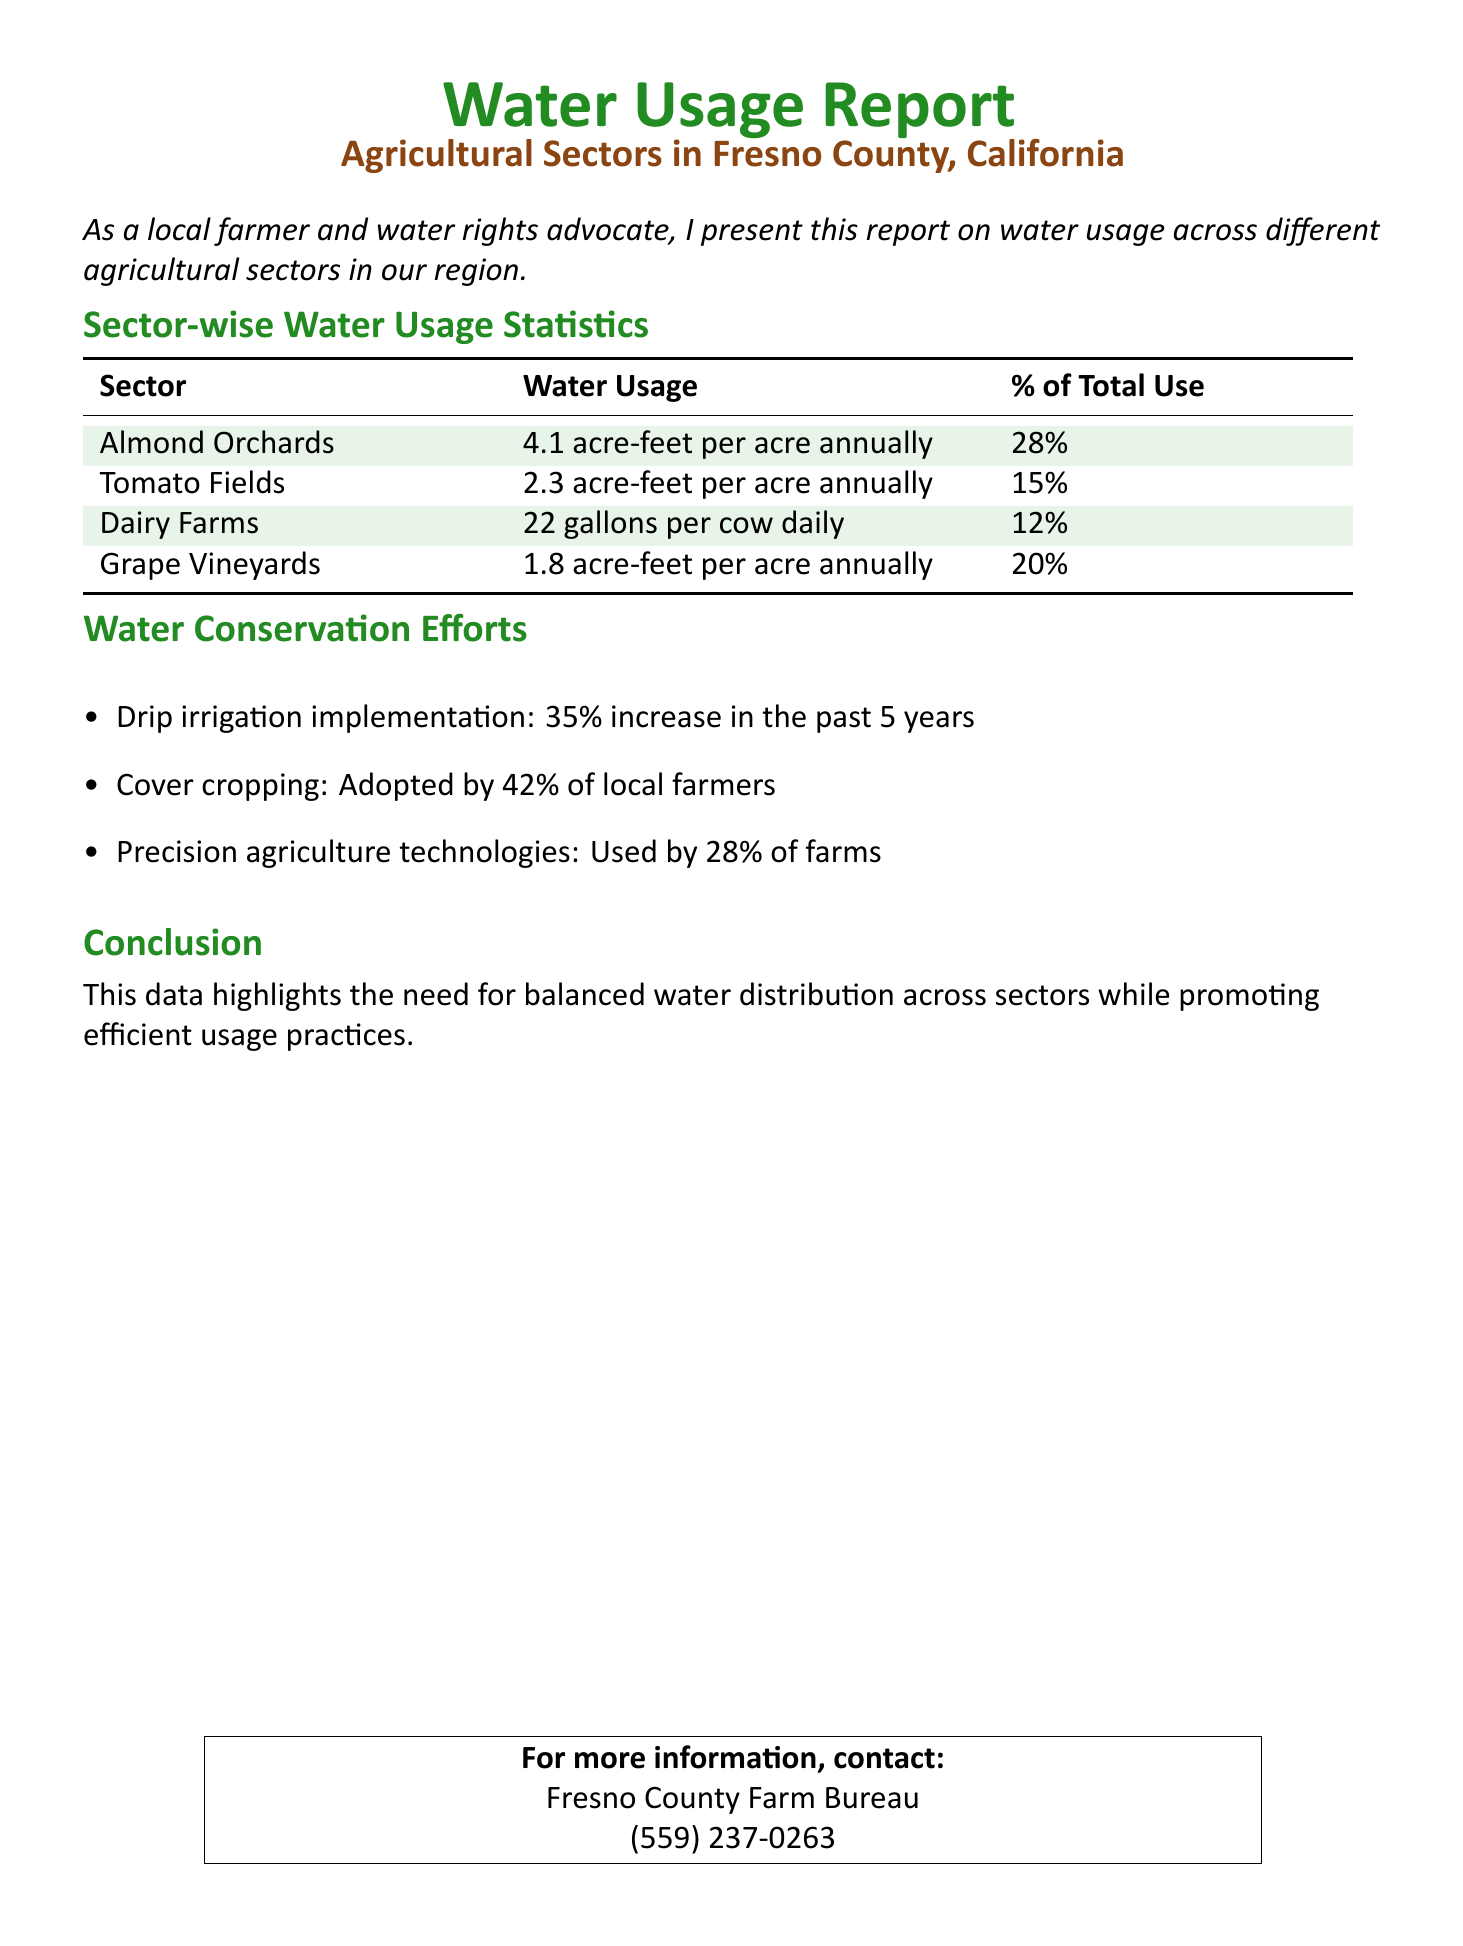What is the water usage for almond orchards? The document specifies that almond orchards use 4.1 acre-feet per acre annually.
Answer: 4.1 acre-feet per acre annually What percentage of total water use is attributed to tomato fields? According to the report, tomato fields account for 15% of total water use.
Answer: 15% How many gallons of water do dairy farms use per cow daily? The document states that dairy farms use 22 gallons per cow daily.
Answer: 22 gallons What is the water usage for grape vineyards? The report indicates that grape vineyards use 1.8 acre-feet per acre annually.
Answer: 1.8 acre-feet per acre annually What percentage of local farmers have adopted cover cropping? The document notes that 42% of local farmers have adopted cover cropping practices.
Answer: 42% What conservation method saw a 35% increase in implementation? Drip irrigation implementation experienced a 35% increase over the past 5 years, as mentioned in the report.
Answer: Drip irrigation What is highlighted as a need in the conclusion of the document? The conclusion emphasizes the need for balanced water distribution across sectors.
Answer: Balanced water distribution What organization can be contacted for more information? The document provides contact details for the Fresno County Farm Bureau for more information.
Answer: Fresno County Farm Bureau 